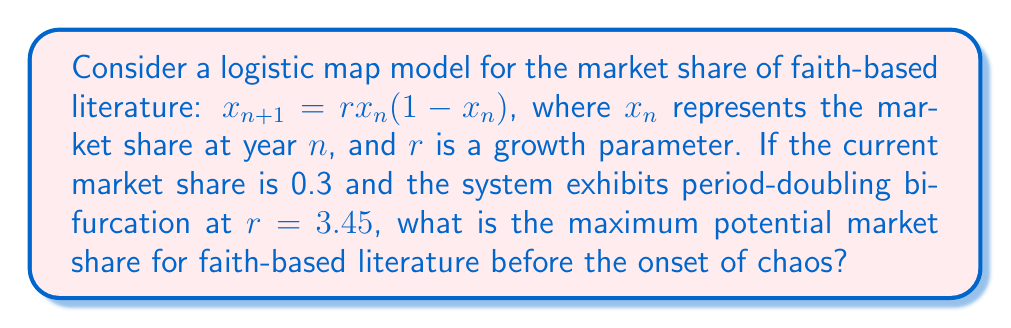Can you solve this math problem? To solve this problem, we need to understand the behavior of the logistic map and its bifurcation diagram:

1. The logistic map is given by $x_{n+1} = rx_n(1-x_n)$, where $0 \leq x_n \leq 1$ and $r > 0$.

2. As $r$ increases, the system undergoes period-doubling bifurcations before transitioning to chaos.

3. The first period-doubling bifurcation occurs at $r = 3$.

4. Subsequent bifurcations occur at shorter intervals, leading to the onset of chaos.

5. The onset of chaos occurs at the accumulation point of the period-doubling cascade, known as the Feigenbaum point.

6. The Feigenbaum point for the logistic map is approximately $r \approx 3.57$.

7. Given that the system exhibits period-doubling bifurcation at $r=3.45$, we know that the system is not yet in chaos but approaching it.

8. The maximum potential market share occurs just before the onset of chaos, at the Feigenbaum point.

9. At the Feigenbaum point, the maximum value of $x_n$ in the attractor is approximately 0.892.

Therefore, the maximum potential market share for faith-based literature before the onset of chaos is approximately 0.892 or 89.2%.
Answer: 0.892 (89.2%) 